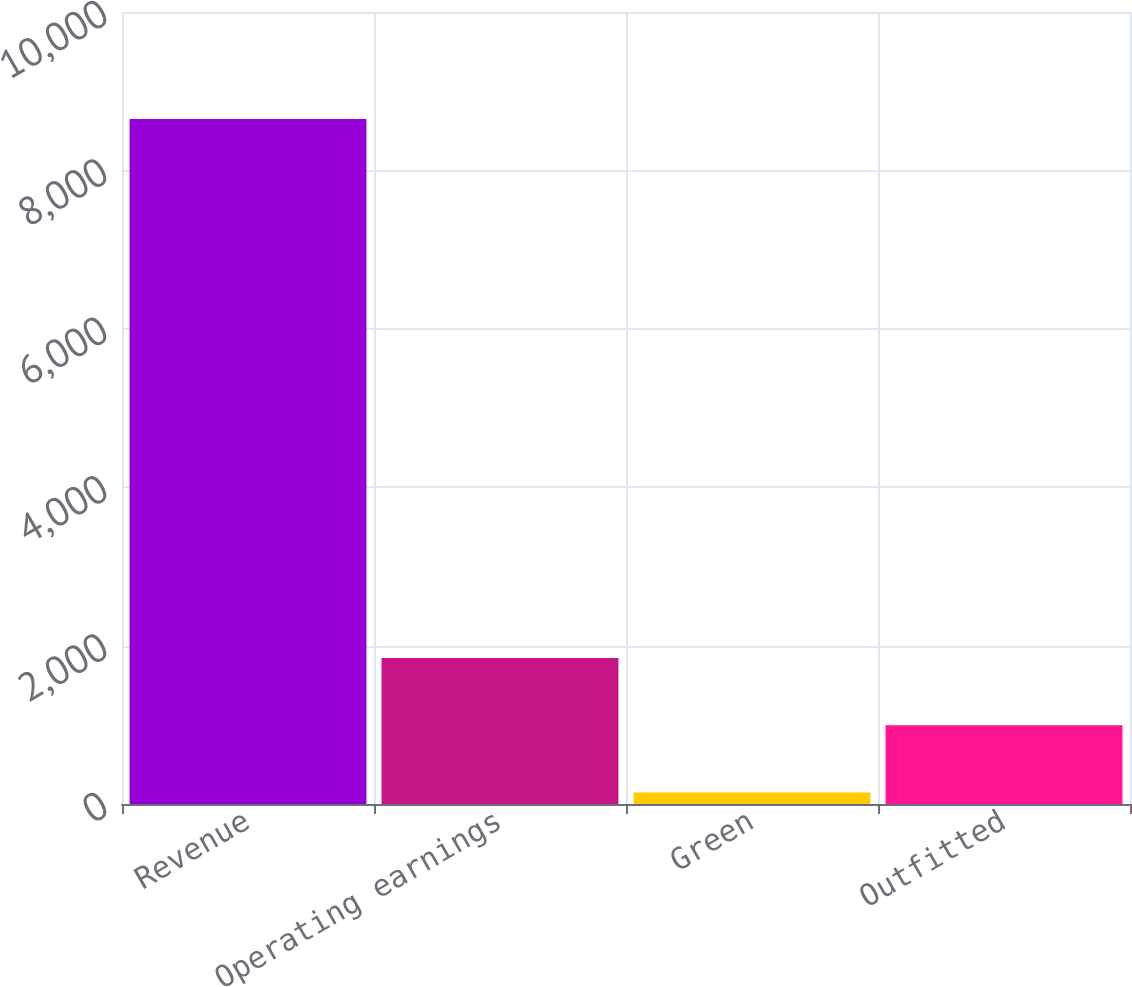Convert chart to OTSL. <chart><loc_0><loc_0><loc_500><loc_500><bar_chart><fcel>Revenue<fcel>Operating earnings<fcel>Green<fcel>Outfitted<nl><fcel>8649<fcel>1845<fcel>144<fcel>994.5<nl></chart> 